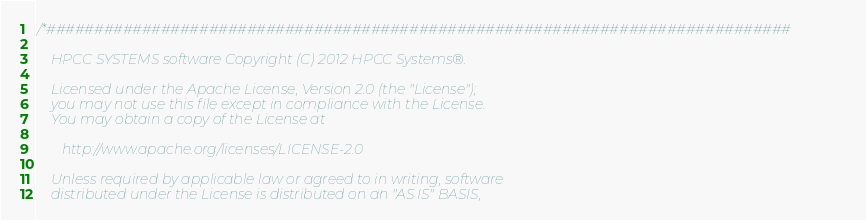Convert code to text. <code><loc_0><loc_0><loc_500><loc_500><_C++_>/*##############################################################################

    HPCC SYSTEMS software Copyright (C) 2012 HPCC Systems®.

    Licensed under the Apache License, Version 2.0 (the "License");
    you may not use this file except in compliance with the License.
    You may obtain a copy of the License at

       http://www.apache.org/licenses/LICENSE-2.0

    Unless required by applicable law or agreed to in writing, software
    distributed under the License is distributed on an "AS IS" BASIS,</code> 